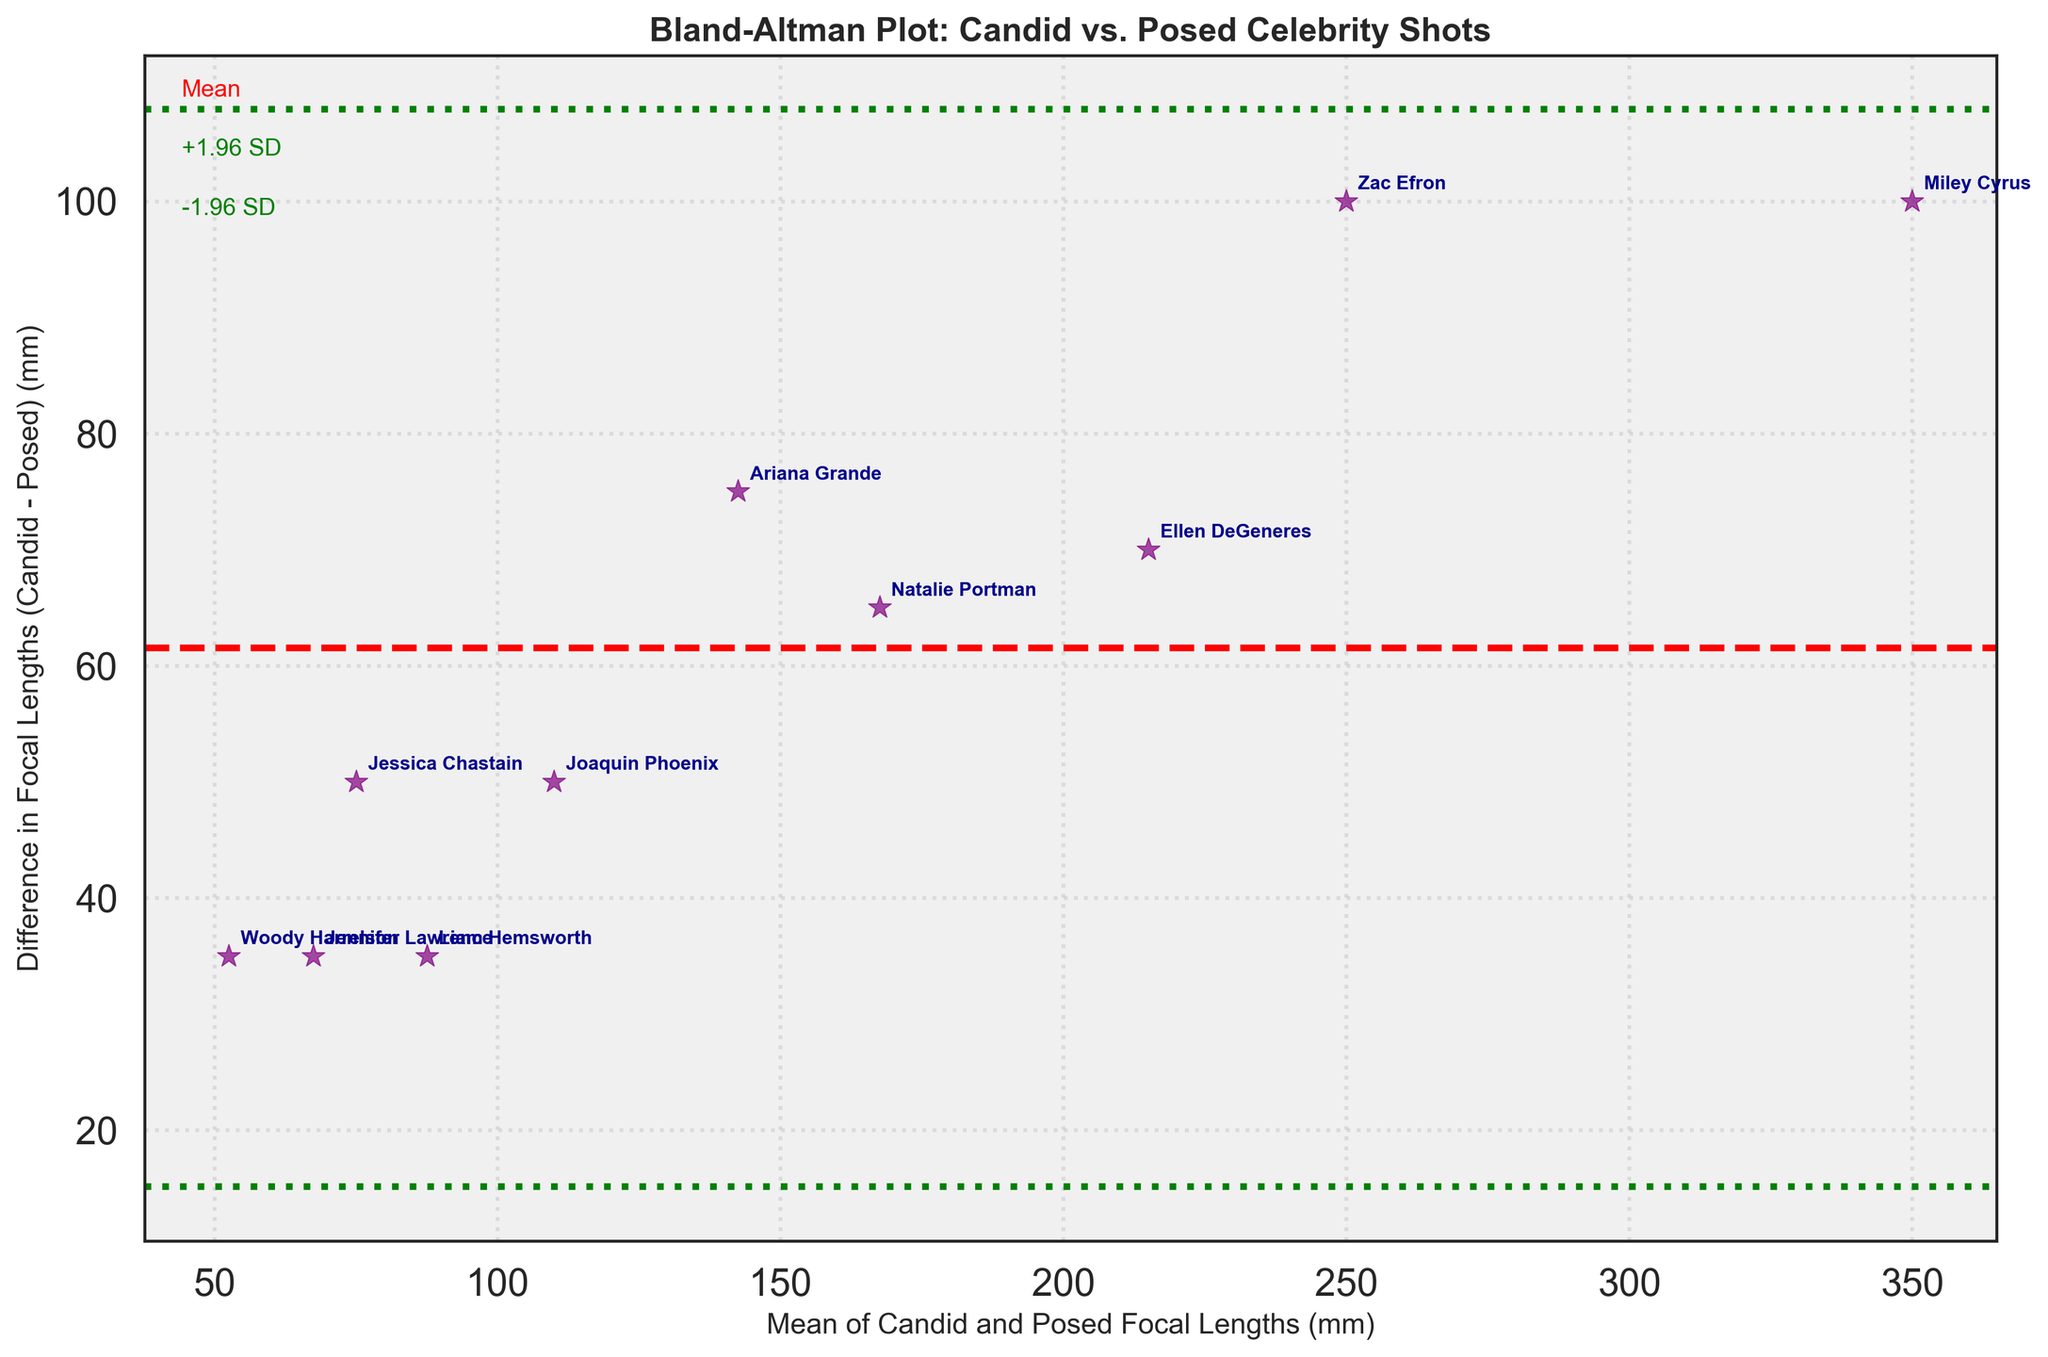What is the title of the plot? The title of the plot is located at the top of the figure in bold text and reads, "Bland-Altman Plot: Candid vs. Posed Celebrity Shots."
Answer: Bland-Altman Plot: Candid vs. Posed Celebrity Shots What are the colors used for the scatter plot points and annotations? The plot points are marked with a purple color and shaped like asterisks, and the annotations (celebrity names) are in dark blue.
Answer: Purple and dark blue How many unique data points are represented in the plot? Each data point corresponds to a celebrity and their respective focal lengths for candid and posed shots. By counting the annotations, we see there are 10 unique data points.
Answer: 10 What is the mean difference in focal lengths between candid and posed shots? The mean difference is visually represented by a red dashed horizontal line. The exact value of the mean difference is shown near the line as "Mean."
Answer: Mean Which celebrities' candid shots used a lens focal length exactly 100 mm longer than their posed shots? To answer this, identify the celebrities whose differences in focal lengths between candid and posed shots are 100 mm, then look for the annotated names for those points.
Answer: Zac Efron and Ellen DeGeneres Which celebrity has the smallest difference in focal lengths between candid and posed shots? The smallest difference can be found by identifying the data point closest to the x-axis (y=0 line). The celebrity name closest to this position will be the one with the smallest difference.
Answer: Jessica Chastain What's the standard deviation of the differences in focal lengths? The standard deviation of the differences is represented by the green dotted lines. These lines mark ±1.96 standard deviations from the mean difference.
Answer: Standard deviation Who has the highest average focal length used for candid and posed shots? Calculate the average focal length by summing the focal lengths of candid and posed shots for each celebrity and then dividing by 2. The highest average value corresponds to the author annotation.
Answer: Miley Cyrus Are there more celebrities with a positive or negative difference in focal lengths? Positive differences occur when the candid focal length is greater than the posed focal length, and negative differences occur when it's smaller. Count the number of data points above and below the zero (x-axis) line to compare.
Answer: Positive Which celeb's mean focal length is closest to 200 mm? Calculate the mean focal length by summing candid and posed focal lengths and dividing by 2. Identify the mean closest to 200 mm and check the annotation.
Answer: Zac Efron 